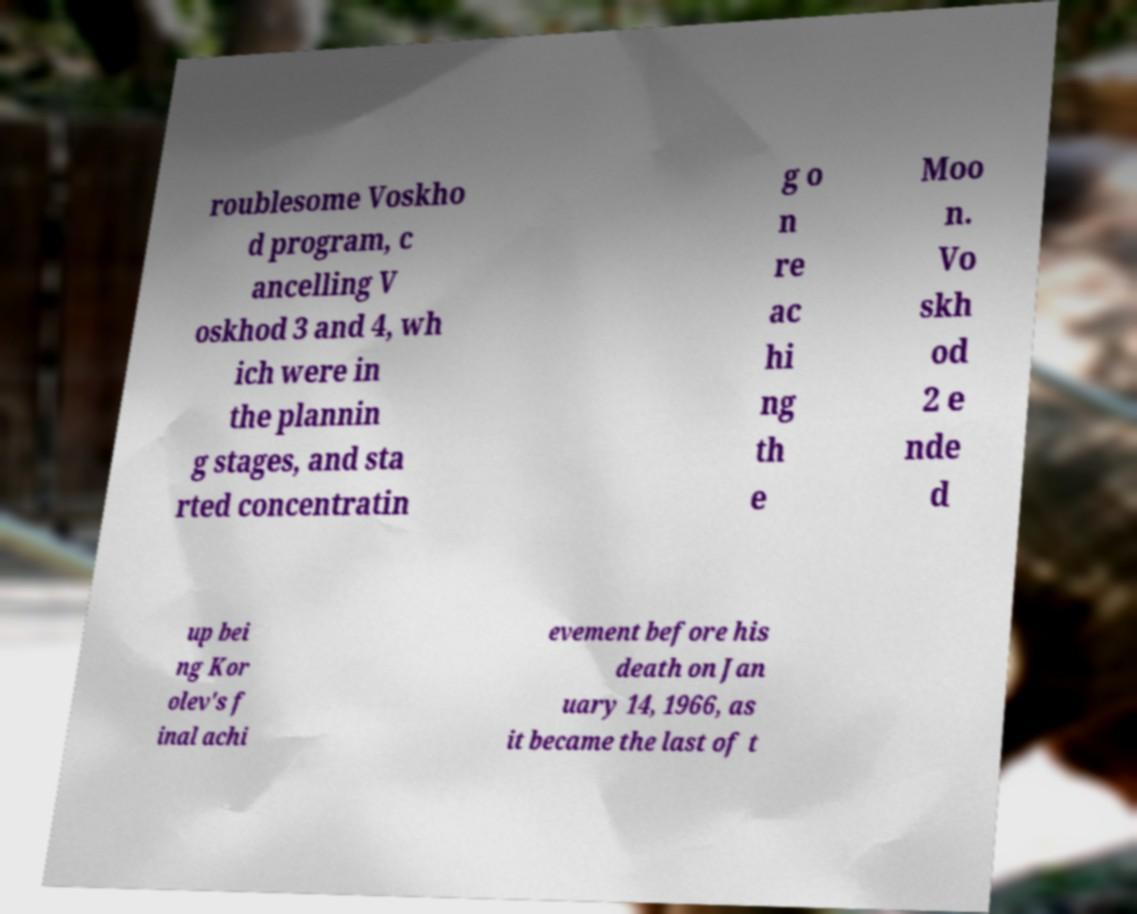Please identify and transcribe the text found in this image. roublesome Voskho d program, c ancelling V oskhod 3 and 4, wh ich were in the plannin g stages, and sta rted concentratin g o n re ac hi ng th e Moo n. Vo skh od 2 e nde d up bei ng Kor olev's f inal achi evement before his death on Jan uary 14, 1966, as it became the last of t 